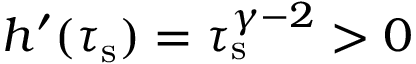Convert formula to latex. <formula><loc_0><loc_0><loc_500><loc_500>h ^ { \prime } ( \tau _ { s } ) = \tau _ { s } ^ { \gamma - 2 } > 0</formula> 